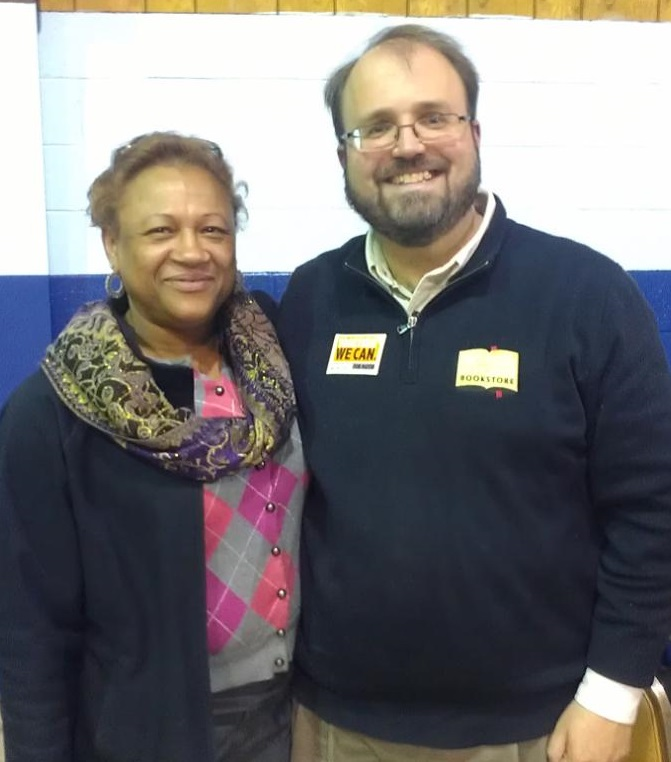Imagine a story where these two individuals are the main characters. What kind of narrative can you create? Meet John and Sarah, two dedicated community activists living in a small, close-knit town. John, a passionate local bookstore owner, and Sarah, a retired teacher with a love for knitting, have been friends for decades. They’re both beloved figures in their community. Today, they’re attending the town’s annual cultural fair, a vibrant event that brings together local artisans, business owners, and performers. This year, the fair holds extra significance as John has been nominated for the ‘Community Hero’ award for his efforts in promoting literacy and Sarah for her volunteer work at the local senior center. Their story is one of friendship, dedication, and the power of community engagement. Can you describe the atmosphere of the cultural fair they are attending? The cultural fair is a lively and colorful event, filled with booths showcasing handmade crafts, local produce, and flavorful foods from various cultures. The air is filled with the sounds of live music, laughter, and the hum of excited conversations. There are performances ranging from folk dances to live bands, engaging the crowd and creating an atmosphere of joy and celebration. It's a place where people of all ages come together to appreciate and share their diverse backgrounds and talents, fostering a strong sense of community and cultural pride. If you could create a fantastical element within this setting, what would it be? Imagine that within this cultural fair, there is a hidden garden that can only be accessed through a magical archway adorned with twinkling lights and mysterious symbols. Inside this garden, rare and enchanted plants grow, each with unique abilities such as granting a temporary ability to speak any language or giving a person extraordinary artistic skills for a day. The garden is maintained by a wise old guardian who resides in a quaint, vine-covered cottage and tells tales of the ancient origins of these plants and their mystical properties to those who seek knowledge and inspiration. 